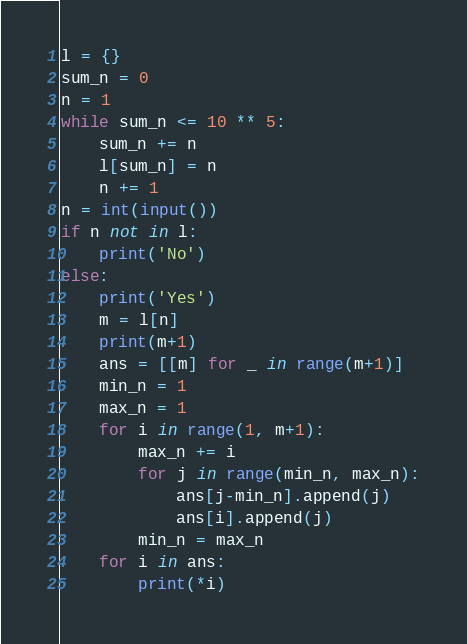<code> <loc_0><loc_0><loc_500><loc_500><_Python_>l = {}
sum_n = 0
n = 1
while sum_n <= 10 ** 5:
    sum_n += n
    l[sum_n] = n
    n += 1
n = int(input())
if n not in l:
    print('No')
else:
    print('Yes')
    m = l[n]
    print(m+1)
    ans = [[m] for _ in range(m+1)]
    min_n = 1
    max_n = 1
    for i in range(1, m+1):
        max_n += i
        for j in range(min_n, max_n):
            ans[j-min_n].append(j)
            ans[i].append(j)
        min_n = max_n
    for i in ans:
        print(*i)
</code> 